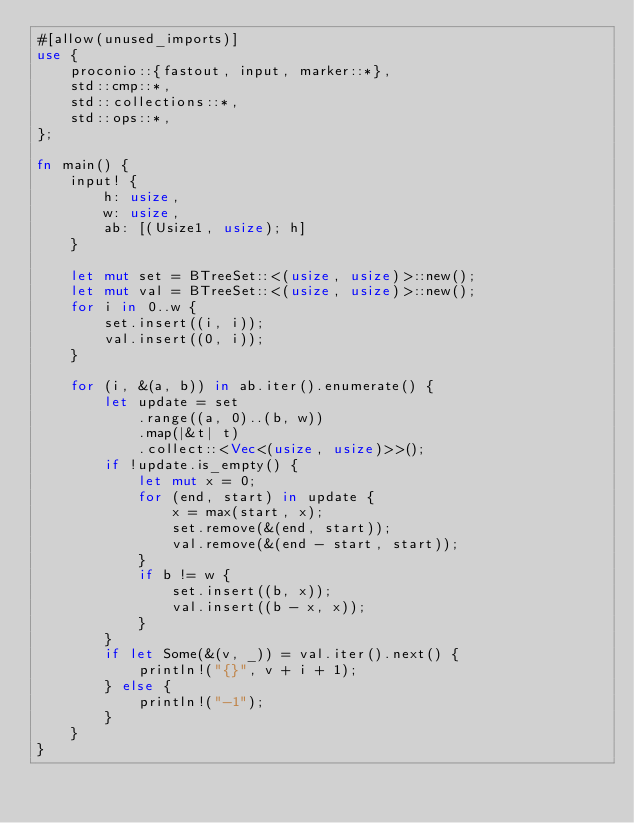Convert code to text. <code><loc_0><loc_0><loc_500><loc_500><_Rust_>#[allow(unused_imports)]
use {
    proconio::{fastout, input, marker::*},
    std::cmp::*,
    std::collections::*,
    std::ops::*,
};

fn main() {
    input! {
        h: usize,
        w: usize,
        ab: [(Usize1, usize); h]
    }

    let mut set = BTreeSet::<(usize, usize)>::new();
    let mut val = BTreeSet::<(usize, usize)>::new();
    for i in 0..w {
        set.insert((i, i));
        val.insert((0, i));
    }

    for (i, &(a, b)) in ab.iter().enumerate() {
        let update = set
            .range((a, 0)..(b, w))
            .map(|&t| t)
            .collect::<Vec<(usize, usize)>>();
        if !update.is_empty() {
            let mut x = 0;
            for (end, start) in update {
                x = max(start, x);
                set.remove(&(end, start));
                val.remove(&(end - start, start));
            }
            if b != w {
                set.insert((b, x));
                val.insert((b - x, x));
            }
        }
        if let Some(&(v, _)) = val.iter().next() {
            println!("{}", v + i + 1);
        } else {
            println!("-1");
        }
    }
}
</code> 